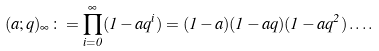<formula> <loc_0><loc_0><loc_500><loc_500>( a ; q ) _ { \infty } \colon = \prod _ { i = 0 } ^ { \infty } ( 1 - a q ^ { i } ) = ( 1 - a ) ( 1 - a q ) ( 1 - a q ^ { 2 } ) \dots .</formula> 